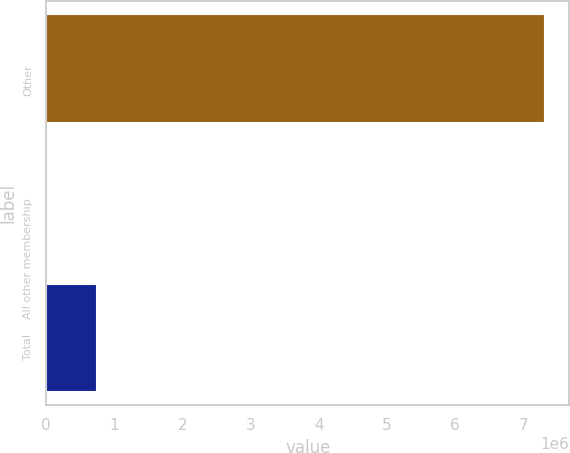<chart> <loc_0><loc_0><loc_500><loc_500><bar_chart><fcel>Other<fcel>All other membership<fcel>Total<nl><fcel>7.3094e+06<fcel>90.8<fcel>731022<nl></chart> 